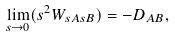Convert formula to latex. <formula><loc_0><loc_0><loc_500><loc_500>\lim _ { s \to 0 } ( s ^ { 2 } W _ { s A s B } ) = - D _ { A B } ,</formula> 